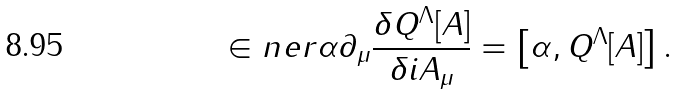<formula> <loc_0><loc_0><loc_500><loc_500>\in n e r { \alpha } { \partial _ { \mu } \frac { \delta Q ^ { \Lambda } [ A ] } { \delta i A _ { \mu } } } = \left [ \alpha , Q ^ { \Lambda } [ A ] \right ] .</formula> 